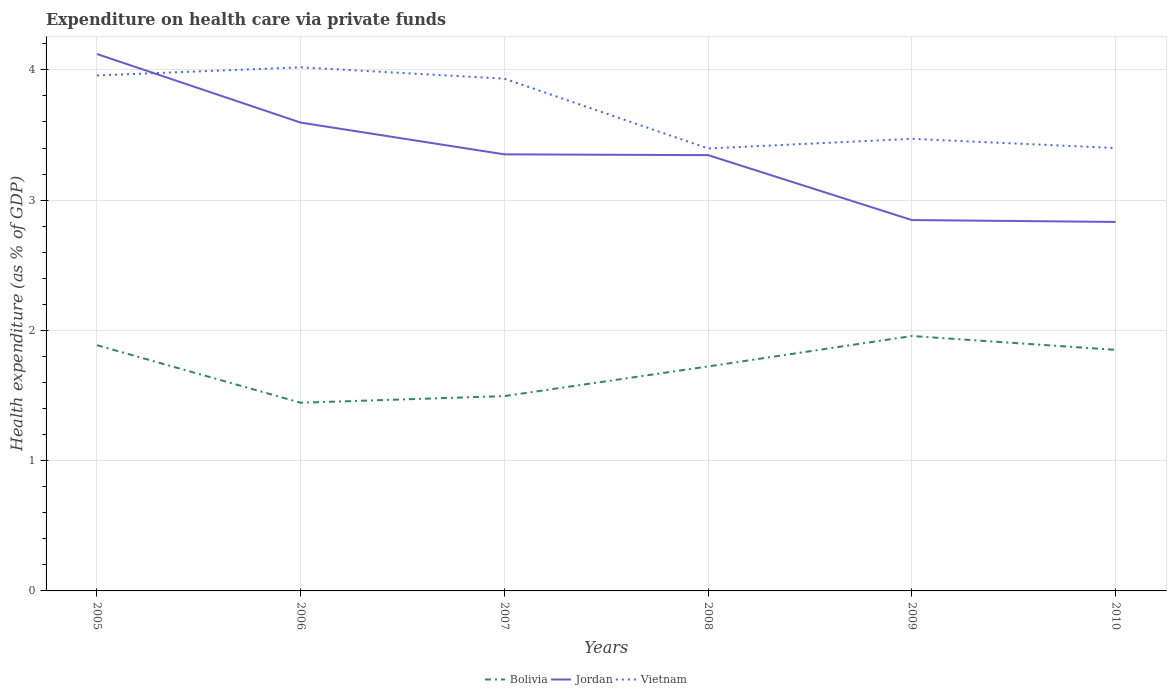Does the line corresponding to Bolivia intersect with the line corresponding to Vietnam?
Keep it short and to the point. No. Is the number of lines equal to the number of legend labels?
Offer a terse response. Yes. Across all years, what is the maximum expenditure made on health care in Bolivia?
Your response must be concise. 1.44. In which year was the expenditure made on health care in Bolivia maximum?
Offer a very short reply. 2006. What is the total expenditure made on health care in Vietnam in the graph?
Provide a short and direct response. -0.07. What is the difference between the highest and the second highest expenditure made on health care in Vietnam?
Offer a terse response. 0.62. What is the difference between the highest and the lowest expenditure made on health care in Bolivia?
Your response must be concise. 3. Is the expenditure made on health care in Vietnam strictly greater than the expenditure made on health care in Bolivia over the years?
Give a very brief answer. No. How many years are there in the graph?
Your answer should be very brief. 6. What is the difference between two consecutive major ticks on the Y-axis?
Provide a succinct answer. 1. Are the values on the major ticks of Y-axis written in scientific E-notation?
Keep it short and to the point. No. Does the graph contain any zero values?
Your answer should be very brief. No. Does the graph contain grids?
Offer a very short reply. Yes. How many legend labels are there?
Give a very brief answer. 3. What is the title of the graph?
Provide a short and direct response. Expenditure on health care via private funds. Does "East Asia (developing only)" appear as one of the legend labels in the graph?
Your answer should be very brief. No. What is the label or title of the X-axis?
Your answer should be compact. Years. What is the label or title of the Y-axis?
Provide a succinct answer. Health expenditure (as % of GDP). What is the Health expenditure (as % of GDP) of Bolivia in 2005?
Provide a short and direct response. 1.89. What is the Health expenditure (as % of GDP) of Jordan in 2005?
Ensure brevity in your answer.  4.12. What is the Health expenditure (as % of GDP) of Vietnam in 2005?
Ensure brevity in your answer.  3.96. What is the Health expenditure (as % of GDP) in Bolivia in 2006?
Your response must be concise. 1.44. What is the Health expenditure (as % of GDP) of Jordan in 2006?
Make the answer very short. 3.6. What is the Health expenditure (as % of GDP) of Vietnam in 2006?
Give a very brief answer. 4.02. What is the Health expenditure (as % of GDP) of Bolivia in 2007?
Keep it short and to the point. 1.5. What is the Health expenditure (as % of GDP) of Jordan in 2007?
Provide a succinct answer. 3.35. What is the Health expenditure (as % of GDP) of Vietnam in 2007?
Make the answer very short. 3.93. What is the Health expenditure (as % of GDP) in Bolivia in 2008?
Offer a very short reply. 1.72. What is the Health expenditure (as % of GDP) of Jordan in 2008?
Your answer should be very brief. 3.35. What is the Health expenditure (as % of GDP) in Vietnam in 2008?
Your answer should be very brief. 3.4. What is the Health expenditure (as % of GDP) of Bolivia in 2009?
Provide a short and direct response. 1.96. What is the Health expenditure (as % of GDP) in Jordan in 2009?
Make the answer very short. 2.85. What is the Health expenditure (as % of GDP) of Vietnam in 2009?
Give a very brief answer. 3.47. What is the Health expenditure (as % of GDP) of Bolivia in 2010?
Give a very brief answer. 1.85. What is the Health expenditure (as % of GDP) of Jordan in 2010?
Ensure brevity in your answer.  2.83. What is the Health expenditure (as % of GDP) of Vietnam in 2010?
Your answer should be very brief. 3.4. Across all years, what is the maximum Health expenditure (as % of GDP) of Bolivia?
Provide a succinct answer. 1.96. Across all years, what is the maximum Health expenditure (as % of GDP) of Jordan?
Make the answer very short. 4.12. Across all years, what is the maximum Health expenditure (as % of GDP) in Vietnam?
Make the answer very short. 4.02. Across all years, what is the minimum Health expenditure (as % of GDP) of Bolivia?
Your response must be concise. 1.44. Across all years, what is the minimum Health expenditure (as % of GDP) of Jordan?
Your response must be concise. 2.83. Across all years, what is the minimum Health expenditure (as % of GDP) of Vietnam?
Your response must be concise. 3.4. What is the total Health expenditure (as % of GDP) in Bolivia in the graph?
Make the answer very short. 10.36. What is the total Health expenditure (as % of GDP) in Jordan in the graph?
Provide a short and direct response. 20.09. What is the total Health expenditure (as % of GDP) in Vietnam in the graph?
Provide a succinct answer. 22.18. What is the difference between the Health expenditure (as % of GDP) of Bolivia in 2005 and that in 2006?
Provide a short and direct response. 0.44. What is the difference between the Health expenditure (as % of GDP) of Jordan in 2005 and that in 2006?
Give a very brief answer. 0.53. What is the difference between the Health expenditure (as % of GDP) of Vietnam in 2005 and that in 2006?
Give a very brief answer. -0.06. What is the difference between the Health expenditure (as % of GDP) in Bolivia in 2005 and that in 2007?
Provide a succinct answer. 0.39. What is the difference between the Health expenditure (as % of GDP) in Jordan in 2005 and that in 2007?
Ensure brevity in your answer.  0.77. What is the difference between the Health expenditure (as % of GDP) in Vietnam in 2005 and that in 2007?
Your response must be concise. 0.02. What is the difference between the Health expenditure (as % of GDP) in Bolivia in 2005 and that in 2008?
Ensure brevity in your answer.  0.16. What is the difference between the Health expenditure (as % of GDP) in Jordan in 2005 and that in 2008?
Provide a succinct answer. 0.78. What is the difference between the Health expenditure (as % of GDP) of Vietnam in 2005 and that in 2008?
Your answer should be very brief. 0.56. What is the difference between the Health expenditure (as % of GDP) of Bolivia in 2005 and that in 2009?
Your response must be concise. -0.07. What is the difference between the Health expenditure (as % of GDP) of Jordan in 2005 and that in 2009?
Make the answer very short. 1.27. What is the difference between the Health expenditure (as % of GDP) of Vietnam in 2005 and that in 2009?
Provide a short and direct response. 0.49. What is the difference between the Health expenditure (as % of GDP) of Bolivia in 2005 and that in 2010?
Keep it short and to the point. 0.04. What is the difference between the Health expenditure (as % of GDP) of Jordan in 2005 and that in 2010?
Offer a very short reply. 1.29. What is the difference between the Health expenditure (as % of GDP) of Vietnam in 2005 and that in 2010?
Ensure brevity in your answer.  0.56. What is the difference between the Health expenditure (as % of GDP) in Bolivia in 2006 and that in 2007?
Give a very brief answer. -0.05. What is the difference between the Health expenditure (as % of GDP) of Jordan in 2006 and that in 2007?
Ensure brevity in your answer.  0.24. What is the difference between the Health expenditure (as % of GDP) of Vietnam in 2006 and that in 2007?
Your answer should be compact. 0.09. What is the difference between the Health expenditure (as % of GDP) of Bolivia in 2006 and that in 2008?
Your answer should be very brief. -0.28. What is the difference between the Health expenditure (as % of GDP) of Jordan in 2006 and that in 2008?
Give a very brief answer. 0.25. What is the difference between the Health expenditure (as % of GDP) in Vietnam in 2006 and that in 2008?
Give a very brief answer. 0.62. What is the difference between the Health expenditure (as % of GDP) in Bolivia in 2006 and that in 2009?
Your answer should be compact. -0.51. What is the difference between the Health expenditure (as % of GDP) of Jordan in 2006 and that in 2009?
Offer a very short reply. 0.75. What is the difference between the Health expenditure (as % of GDP) of Vietnam in 2006 and that in 2009?
Make the answer very short. 0.55. What is the difference between the Health expenditure (as % of GDP) in Bolivia in 2006 and that in 2010?
Your answer should be very brief. -0.41. What is the difference between the Health expenditure (as % of GDP) in Jordan in 2006 and that in 2010?
Make the answer very short. 0.76. What is the difference between the Health expenditure (as % of GDP) of Vietnam in 2006 and that in 2010?
Provide a short and direct response. 0.62. What is the difference between the Health expenditure (as % of GDP) of Bolivia in 2007 and that in 2008?
Offer a terse response. -0.23. What is the difference between the Health expenditure (as % of GDP) in Jordan in 2007 and that in 2008?
Provide a short and direct response. 0.01. What is the difference between the Health expenditure (as % of GDP) of Vietnam in 2007 and that in 2008?
Provide a succinct answer. 0.54. What is the difference between the Health expenditure (as % of GDP) of Bolivia in 2007 and that in 2009?
Your response must be concise. -0.46. What is the difference between the Health expenditure (as % of GDP) of Jordan in 2007 and that in 2009?
Your answer should be very brief. 0.5. What is the difference between the Health expenditure (as % of GDP) of Vietnam in 2007 and that in 2009?
Give a very brief answer. 0.46. What is the difference between the Health expenditure (as % of GDP) in Bolivia in 2007 and that in 2010?
Make the answer very short. -0.35. What is the difference between the Health expenditure (as % of GDP) in Jordan in 2007 and that in 2010?
Offer a terse response. 0.52. What is the difference between the Health expenditure (as % of GDP) in Vietnam in 2007 and that in 2010?
Your response must be concise. 0.53. What is the difference between the Health expenditure (as % of GDP) in Bolivia in 2008 and that in 2009?
Provide a succinct answer. -0.23. What is the difference between the Health expenditure (as % of GDP) in Jordan in 2008 and that in 2009?
Offer a terse response. 0.5. What is the difference between the Health expenditure (as % of GDP) in Vietnam in 2008 and that in 2009?
Your response must be concise. -0.07. What is the difference between the Health expenditure (as % of GDP) in Bolivia in 2008 and that in 2010?
Your answer should be very brief. -0.13. What is the difference between the Health expenditure (as % of GDP) of Jordan in 2008 and that in 2010?
Offer a terse response. 0.51. What is the difference between the Health expenditure (as % of GDP) of Vietnam in 2008 and that in 2010?
Provide a short and direct response. -0. What is the difference between the Health expenditure (as % of GDP) of Bolivia in 2009 and that in 2010?
Offer a very short reply. 0.11. What is the difference between the Health expenditure (as % of GDP) of Jordan in 2009 and that in 2010?
Make the answer very short. 0.01. What is the difference between the Health expenditure (as % of GDP) in Vietnam in 2009 and that in 2010?
Provide a succinct answer. 0.07. What is the difference between the Health expenditure (as % of GDP) of Bolivia in 2005 and the Health expenditure (as % of GDP) of Jordan in 2006?
Offer a very short reply. -1.71. What is the difference between the Health expenditure (as % of GDP) in Bolivia in 2005 and the Health expenditure (as % of GDP) in Vietnam in 2006?
Your answer should be compact. -2.13. What is the difference between the Health expenditure (as % of GDP) of Jordan in 2005 and the Health expenditure (as % of GDP) of Vietnam in 2006?
Give a very brief answer. 0.1. What is the difference between the Health expenditure (as % of GDP) of Bolivia in 2005 and the Health expenditure (as % of GDP) of Jordan in 2007?
Ensure brevity in your answer.  -1.47. What is the difference between the Health expenditure (as % of GDP) of Bolivia in 2005 and the Health expenditure (as % of GDP) of Vietnam in 2007?
Ensure brevity in your answer.  -2.05. What is the difference between the Health expenditure (as % of GDP) in Jordan in 2005 and the Health expenditure (as % of GDP) in Vietnam in 2007?
Your response must be concise. 0.19. What is the difference between the Health expenditure (as % of GDP) of Bolivia in 2005 and the Health expenditure (as % of GDP) of Jordan in 2008?
Offer a very short reply. -1.46. What is the difference between the Health expenditure (as % of GDP) in Bolivia in 2005 and the Health expenditure (as % of GDP) in Vietnam in 2008?
Your answer should be very brief. -1.51. What is the difference between the Health expenditure (as % of GDP) in Jordan in 2005 and the Health expenditure (as % of GDP) in Vietnam in 2008?
Give a very brief answer. 0.73. What is the difference between the Health expenditure (as % of GDP) of Bolivia in 2005 and the Health expenditure (as % of GDP) of Jordan in 2009?
Make the answer very short. -0.96. What is the difference between the Health expenditure (as % of GDP) of Bolivia in 2005 and the Health expenditure (as % of GDP) of Vietnam in 2009?
Offer a terse response. -1.58. What is the difference between the Health expenditure (as % of GDP) in Jordan in 2005 and the Health expenditure (as % of GDP) in Vietnam in 2009?
Offer a very short reply. 0.65. What is the difference between the Health expenditure (as % of GDP) in Bolivia in 2005 and the Health expenditure (as % of GDP) in Jordan in 2010?
Give a very brief answer. -0.95. What is the difference between the Health expenditure (as % of GDP) of Bolivia in 2005 and the Health expenditure (as % of GDP) of Vietnam in 2010?
Provide a short and direct response. -1.51. What is the difference between the Health expenditure (as % of GDP) of Jordan in 2005 and the Health expenditure (as % of GDP) of Vietnam in 2010?
Provide a short and direct response. 0.72. What is the difference between the Health expenditure (as % of GDP) of Bolivia in 2006 and the Health expenditure (as % of GDP) of Jordan in 2007?
Your answer should be very brief. -1.91. What is the difference between the Health expenditure (as % of GDP) in Bolivia in 2006 and the Health expenditure (as % of GDP) in Vietnam in 2007?
Your response must be concise. -2.49. What is the difference between the Health expenditure (as % of GDP) of Jordan in 2006 and the Health expenditure (as % of GDP) of Vietnam in 2007?
Make the answer very short. -0.34. What is the difference between the Health expenditure (as % of GDP) in Bolivia in 2006 and the Health expenditure (as % of GDP) in Jordan in 2008?
Offer a terse response. -1.9. What is the difference between the Health expenditure (as % of GDP) of Bolivia in 2006 and the Health expenditure (as % of GDP) of Vietnam in 2008?
Offer a very short reply. -1.95. What is the difference between the Health expenditure (as % of GDP) in Jordan in 2006 and the Health expenditure (as % of GDP) in Vietnam in 2008?
Your response must be concise. 0.2. What is the difference between the Health expenditure (as % of GDP) in Bolivia in 2006 and the Health expenditure (as % of GDP) in Jordan in 2009?
Your answer should be compact. -1.4. What is the difference between the Health expenditure (as % of GDP) in Bolivia in 2006 and the Health expenditure (as % of GDP) in Vietnam in 2009?
Provide a succinct answer. -2.03. What is the difference between the Health expenditure (as % of GDP) of Jordan in 2006 and the Health expenditure (as % of GDP) of Vietnam in 2009?
Your response must be concise. 0.12. What is the difference between the Health expenditure (as % of GDP) in Bolivia in 2006 and the Health expenditure (as % of GDP) in Jordan in 2010?
Keep it short and to the point. -1.39. What is the difference between the Health expenditure (as % of GDP) of Bolivia in 2006 and the Health expenditure (as % of GDP) of Vietnam in 2010?
Offer a very short reply. -1.96. What is the difference between the Health expenditure (as % of GDP) in Jordan in 2006 and the Health expenditure (as % of GDP) in Vietnam in 2010?
Your answer should be compact. 0.2. What is the difference between the Health expenditure (as % of GDP) of Bolivia in 2007 and the Health expenditure (as % of GDP) of Jordan in 2008?
Your answer should be very brief. -1.85. What is the difference between the Health expenditure (as % of GDP) of Bolivia in 2007 and the Health expenditure (as % of GDP) of Vietnam in 2008?
Make the answer very short. -1.9. What is the difference between the Health expenditure (as % of GDP) in Jordan in 2007 and the Health expenditure (as % of GDP) in Vietnam in 2008?
Ensure brevity in your answer.  -0.05. What is the difference between the Health expenditure (as % of GDP) of Bolivia in 2007 and the Health expenditure (as % of GDP) of Jordan in 2009?
Your response must be concise. -1.35. What is the difference between the Health expenditure (as % of GDP) of Bolivia in 2007 and the Health expenditure (as % of GDP) of Vietnam in 2009?
Provide a short and direct response. -1.98. What is the difference between the Health expenditure (as % of GDP) in Jordan in 2007 and the Health expenditure (as % of GDP) in Vietnam in 2009?
Provide a succinct answer. -0.12. What is the difference between the Health expenditure (as % of GDP) of Bolivia in 2007 and the Health expenditure (as % of GDP) of Jordan in 2010?
Ensure brevity in your answer.  -1.34. What is the difference between the Health expenditure (as % of GDP) in Bolivia in 2007 and the Health expenditure (as % of GDP) in Vietnam in 2010?
Keep it short and to the point. -1.9. What is the difference between the Health expenditure (as % of GDP) in Jordan in 2007 and the Health expenditure (as % of GDP) in Vietnam in 2010?
Provide a short and direct response. -0.05. What is the difference between the Health expenditure (as % of GDP) of Bolivia in 2008 and the Health expenditure (as % of GDP) of Jordan in 2009?
Your answer should be compact. -1.12. What is the difference between the Health expenditure (as % of GDP) in Bolivia in 2008 and the Health expenditure (as % of GDP) in Vietnam in 2009?
Give a very brief answer. -1.75. What is the difference between the Health expenditure (as % of GDP) in Jordan in 2008 and the Health expenditure (as % of GDP) in Vietnam in 2009?
Provide a short and direct response. -0.13. What is the difference between the Health expenditure (as % of GDP) of Bolivia in 2008 and the Health expenditure (as % of GDP) of Jordan in 2010?
Your answer should be very brief. -1.11. What is the difference between the Health expenditure (as % of GDP) in Bolivia in 2008 and the Health expenditure (as % of GDP) in Vietnam in 2010?
Make the answer very short. -1.68. What is the difference between the Health expenditure (as % of GDP) in Jordan in 2008 and the Health expenditure (as % of GDP) in Vietnam in 2010?
Ensure brevity in your answer.  -0.05. What is the difference between the Health expenditure (as % of GDP) of Bolivia in 2009 and the Health expenditure (as % of GDP) of Jordan in 2010?
Your answer should be compact. -0.88. What is the difference between the Health expenditure (as % of GDP) of Bolivia in 2009 and the Health expenditure (as % of GDP) of Vietnam in 2010?
Make the answer very short. -1.44. What is the difference between the Health expenditure (as % of GDP) of Jordan in 2009 and the Health expenditure (as % of GDP) of Vietnam in 2010?
Your answer should be very brief. -0.55. What is the average Health expenditure (as % of GDP) of Bolivia per year?
Make the answer very short. 1.73. What is the average Health expenditure (as % of GDP) of Jordan per year?
Provide a short and direct response. 3.35. What is the average Health expenditure (as % of GDP) of Vietnam per year?
Offer a very short reply. 3.7. In the year 2005, what is the difference between the Health expenditure (as % of GDP) of Bolivia and Health expenditure (as % of GDP) of Jordan?
Your answer should be compact. -2.24. In the year 2005, what is the difference between the Health expenditure (as % of GDP) of Bolivia and Health expenditure (as % of GDP) of Vietnam?
Keep it short and to the point. -2.07. In the year 2005, what is the difference between the Health expenditure (as % of GDP) of Jordan and Health expenditure (as % of GDP) of Vietnam?
Provide a succinct answer. 0.16. In the year 2006, what is the difference between the Health expenditure (as % of GDP) in Bolivia and Health expenditure (as % of GDP) in Jordan?
Offer a terse response. -2.15. In the year 2006, what is the difference between the Health expenditure (as % of GDP) in Bolivia and Health expenditure (as % of GDP) in Vietnam?
Make the answer very short. -2.57. In the year 2006, what is the difference between the Health expenditure (as % of GDP) of Jordan and Health expenditure (as % of GDP) of Vietnam?
Your answer should be compact. -0.42. In the year 2007, what is the difference between the Health expenditure (as % of GDP) of Bolivia and Health expenditure (as % of GDP) of Jordan?
Keep it short and to the point. -1.86. In the year 2007, what is the difference between the Health expenditure (as % of GDP) of Bolivia and Health expenditure (as % of GDP) of Vietnam?
Make the answer very short. -2.44. In the year 2007, what is the difference between the Health expenditure (as % of GDP) of Jordan and Health expenditure (as % of GDP) of Vietnam?
Make the answer very short. -0.58. In the year 2008, what is the difference between the Health expenditure (as % of GDP) in Bolivia and Health expenditure (as % of GDP) in Jordan?
Offer a very short reply. -1.62. In the year 2008, what is the difference between the Health expenditure (as % of GDP) of Bolivia and Health expenditure (as % of GDP) of Vietnam?
Your response must be concise. -1.67. In the year 2008, what is the difference between the Health expenditure (as % of GDP) of Jordan and Health expenditure (as % of GDP) of Vietnam?
Offer a very short reply. -0.05. In the year 2009, what is the difference between the Health expenditure (as % of GDP) in Bolivia and Health expenditure (as % of GDP) in Jordan?
Offer a terse response. -0.89. In the year 2009, what is the difference between the Health expenditure (as % of GDP) in Bolivia and Health expenditure (as % of GDP) in Vietnam?
Offer a terse response. -1.51. In the year 2009, what is the difference between the Health expenditure (as % of GDP) of Jordan and Health expenditure (as % of GDP) of Vietnam?
Make the answer very short. -0.62. In the year 2010, what is the difference between the Health expenditure (as % of GDP) in Bolivia and Health expenditure (as % of GDP) in Jordan?
Your response must be concise. -0.98. In the year 2010, what is the difference between the Health expenditure (as % of GDP) in Bolivia and Health expenditure (as % of GDP) in Vietnam?
Offer a terse response. -1.55. In the year 2010, what is the difference between the Health expenditure (as % of GDP) of Jordan and Health expenditure (as % of GDP) of Vietnam?
Give a very brief answer. -0.57. What is the ratio of the Health expenditure (as % of GDP) in Bolivia in 2005 to that in 2006?
Your answer should be very brief. 1.31. What is the ratio of the Health expenditure (as % of GDP) of Jordan in 2005 to that in 2006?
Ensure brevity in your answer.  1.15. What is the ratio of the Health expenditure (as % of GDP) in Vietnam in 2005 to that in 2006?
Provide a short and direct response. 0.98. What is the ratio of the Health expenditure (as % of GDP) in Bolivia in 2005 to that in 2007?
Ensure brevity in your answer.  1.26. What is the ratio of the Health expenditure (as % of GDP) in Jordan in 2005 to that in 2007?
Your answer should be compact. 1.23. What is the ratio of the Health expenditure (as % of GDP) in Vietnam in 2005 to that in 2007?
Offer a terse response. 1.01. What is the ratio of the Health expenditure (as % of GDP) in Bolivia in 2005 to that in 2008?
Your answer should be compact. 1.09. What is the ratio of the Health expenditure (as % of GDP) in Jordan in 2005 to that in 2008?
Provide a succinct answer. 1.23. What is the ratio of the Health expenditure (as % of GDP) in Vietnam in 2005 to that in 2008?
Offer a very short reply. 1.17. What is the ratio of the Health expenditure (as % of GDP) of Jordan in 2005 to that in 2009?
Give a very brief answer. 1.45. What is the ratio of the Health expenditure (as % of GDP) of Vietnam in 2005 to that in 2009?
Make the answer very short. 1.14. What is the ratio of the Health expenditure (as % of GDP) of Bolivia in 2005 to that in 2010?
Keep it short and to the point. 1.02. What is the ratio of the Health expenditure (as % of GDP) of Jordan in 2005 to that in 2010?
Provide a short and direct response. 1.46. What is the ratio of the Health expenditure (as % of GDP) of Vietnam in 2005 to that in 2010?
Keep it short and to the point. 1.16. What is the ratio of the Health expenditure (as % of GDP) of Bolivia in 2006 to that in 2007?
Ensure brevity in your answer.  0.97. What is the ratio of the Health expenditure (as % of GDP) in Jordan in 2006 to that in 2007?
Offer a terse response. 1.07. What is the ratio of the Health expenditure (as % of GDP) in Vietnam in 2006 to that in 2007?
Offer a very short reply. 1.02. What is the ratio of the Health expenditure (as % of GDP) of Bolivia in 2006 to that in 2008?
Provide a succinct answer. 0.84. What is the ratio of the Health expenditure (as % of GDP) of Jordan in 2006 to that in 2008?
Ensure brevity in your answer.  1.07. What is the ratio of the Health expenditure (as % of GDP) of Vietnam in 2006 to that in 2008?
Give a very brief answer. 1.18. What is the ratio of the Health expenditure (as % of GDP) of Bolivia in 2006 to that in 2009?
Your answer should be very brief. 0.74. What is the ratio of the Health expenditure (as % of GDP) of Jordan in 2006 to that in 2009?
Provide a succinct answer. 1.26. What is the ratio of the Health expenditure (as % of GDP) of Vietnam in 2006 to that in 2009?
Make the answer very short. 1.16. What is the ratio of the Health expenditure (as % of GDP) in Bolivia in 2006 to that in 2010?
Your answer should be very brief. 0.78. What is the ratio of the Health expenditure (as % of GDP) of Jordan in 2006 to that in 2010?
Your response must be concise. 1.27. What is the ratio of the Health expenditure (as % of GDP) in Vietnam in 2006 to that in 2010?
Your answer should be very brief. 1.18. What is the ratio of the Health expenditure (as % of GDP) in Bolivia in 2007 to that in 2008?
Make the answer very short. 0.87. What is the ratio of the Health expenditure (as % of GDP) in Vietnam in 2007 to that in 2008?
Ensure brevity in your answer.  1.16. What is the ratio of the Health expenditure (as % of GDP) of Bolivia in 2007 to that in 2009?
Your answer should be very brief. 0.76. What is the ratio of the Health expenditure (as % of GDP) of Jordan in 2007 to that in 2009?
Your answer should be very brief. 1.18. What is the ratio of the Health expenditure (as % of GDP) of Vietnam in 2007 to that in 2009?
Offer a very short reply. 1.13. What is the ratio of the Health expenditure (as % of GDP) of Bolivia in 2007 to that in 2010?
Keep it short and to the point. 0.81. What is the ratio of the Health expenditure (as % of GDP) in Jordan in 2007 to that in 2010?
Offer a very short reply. 1.18. What is the ratio of the Health expenditure (as % of GDP) in Vietnam in 2007 to that in 2010?
Make the answer very short. 1.16. What is the ratio of the Health expenditure (as % of GDP) of Bolivia in 2008 to that in 2009?
Offer a terse response. 0.88. What is the ratio of the Health expenditure (as % of GDP) in Jordan in 2008 to that in 2009?
Ensure brevity in your answer.  1.18. What is the ratio of the Health expenditure (as % of GDP) in Vietnam in 2008 to that in 2009?
Ensure brevity in your answer.  0.98. What is the ratio of the Health expenditure (as % of GDP) of Bolivia in 2008 to that in 2010?
Ensure brevity in your answer.  0.93. What is the ratio of the Health expenditure (as % of GDP) of Jordan in 2008 to that in 2010?
Offer a very short reply. 1.18. What is the ratio of the Health expenditure (as % of GDP) of Bolivia in 2009 to that in 2010?
Your answer should be compact. 1.06. What is the ratio of the Health expenditure (as % of GDP) in Vietnam in 2009 to that in 2010?
Your response must be concise. 1.02. What is the difference between the highest and the second highest Health expenditure (as % of GDP) in Bolivia?
Your answer should be compact. 0.07. What is the difference between the highest and the second highest Health expenditure (as % of GDP) in Jordan?
Your answer should be compact. 0.53. What is the difference between the highest and the second highest Health expenditure (as % of GDP) in Vietnam?
Make the answer very short. 0.06. What is the difference between the highest and the lowest Health expenditure (as % of GDP) in Bolivia?
Your response must be concise. 0.51. What is the difference between the highest and the lowest Health expenditure (as % of GDP) in Jordan?
Ensure brevity in your answer.  1.29. What is the difference between the highest and the lowest Health expenditure (as % of GDP) of Vietnam?
Offer a very short reply. 0.62. 